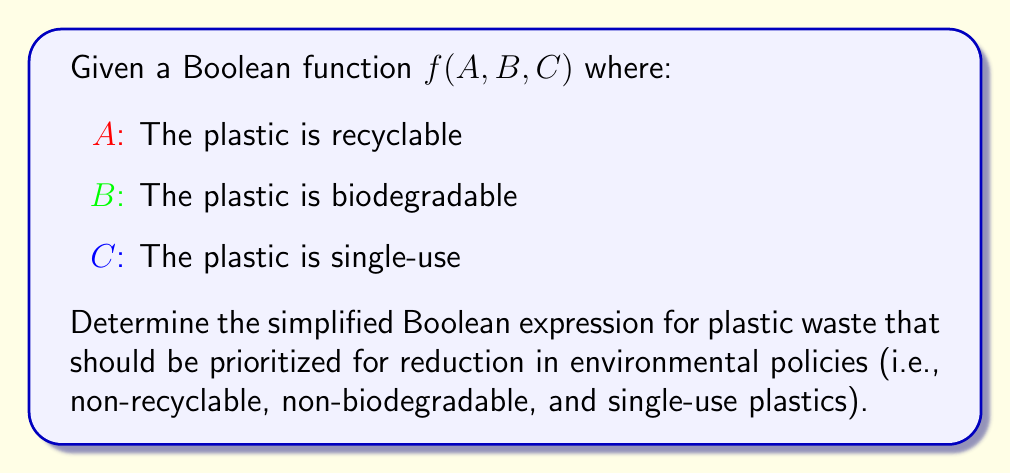Solve this math problem. Let's approach this step-by-step:

1) We want to identify plastics that are:
   - Not recyclable (¬A)
   - Not biodegradable (¬B)
   - Single-use (C)

2) We can express this as a Boolean function:
   $f(A, B, C) = \overline{A} \cdot \overline{B} \cdot C$

3) This function is already in its simplest form, as it's a product of three terms (two of which are negated).

4) In terms of a truth table, this function would return 1 (true) only when A = 0, B = 0, and C = 1.

5) From a policy perspective, this Boolean function helps identify the most problematic plastic waste types that should be targeted for reduction or elimination.

6) The simplified Boolean expression is already $\overline{A} \cdot \overline{B} \cdot C$, which directly translates to "not recyclable AND not biodegradable AND single-use".
Answer: $\overline{A} \cdot \overline{B} \cdot C$ 